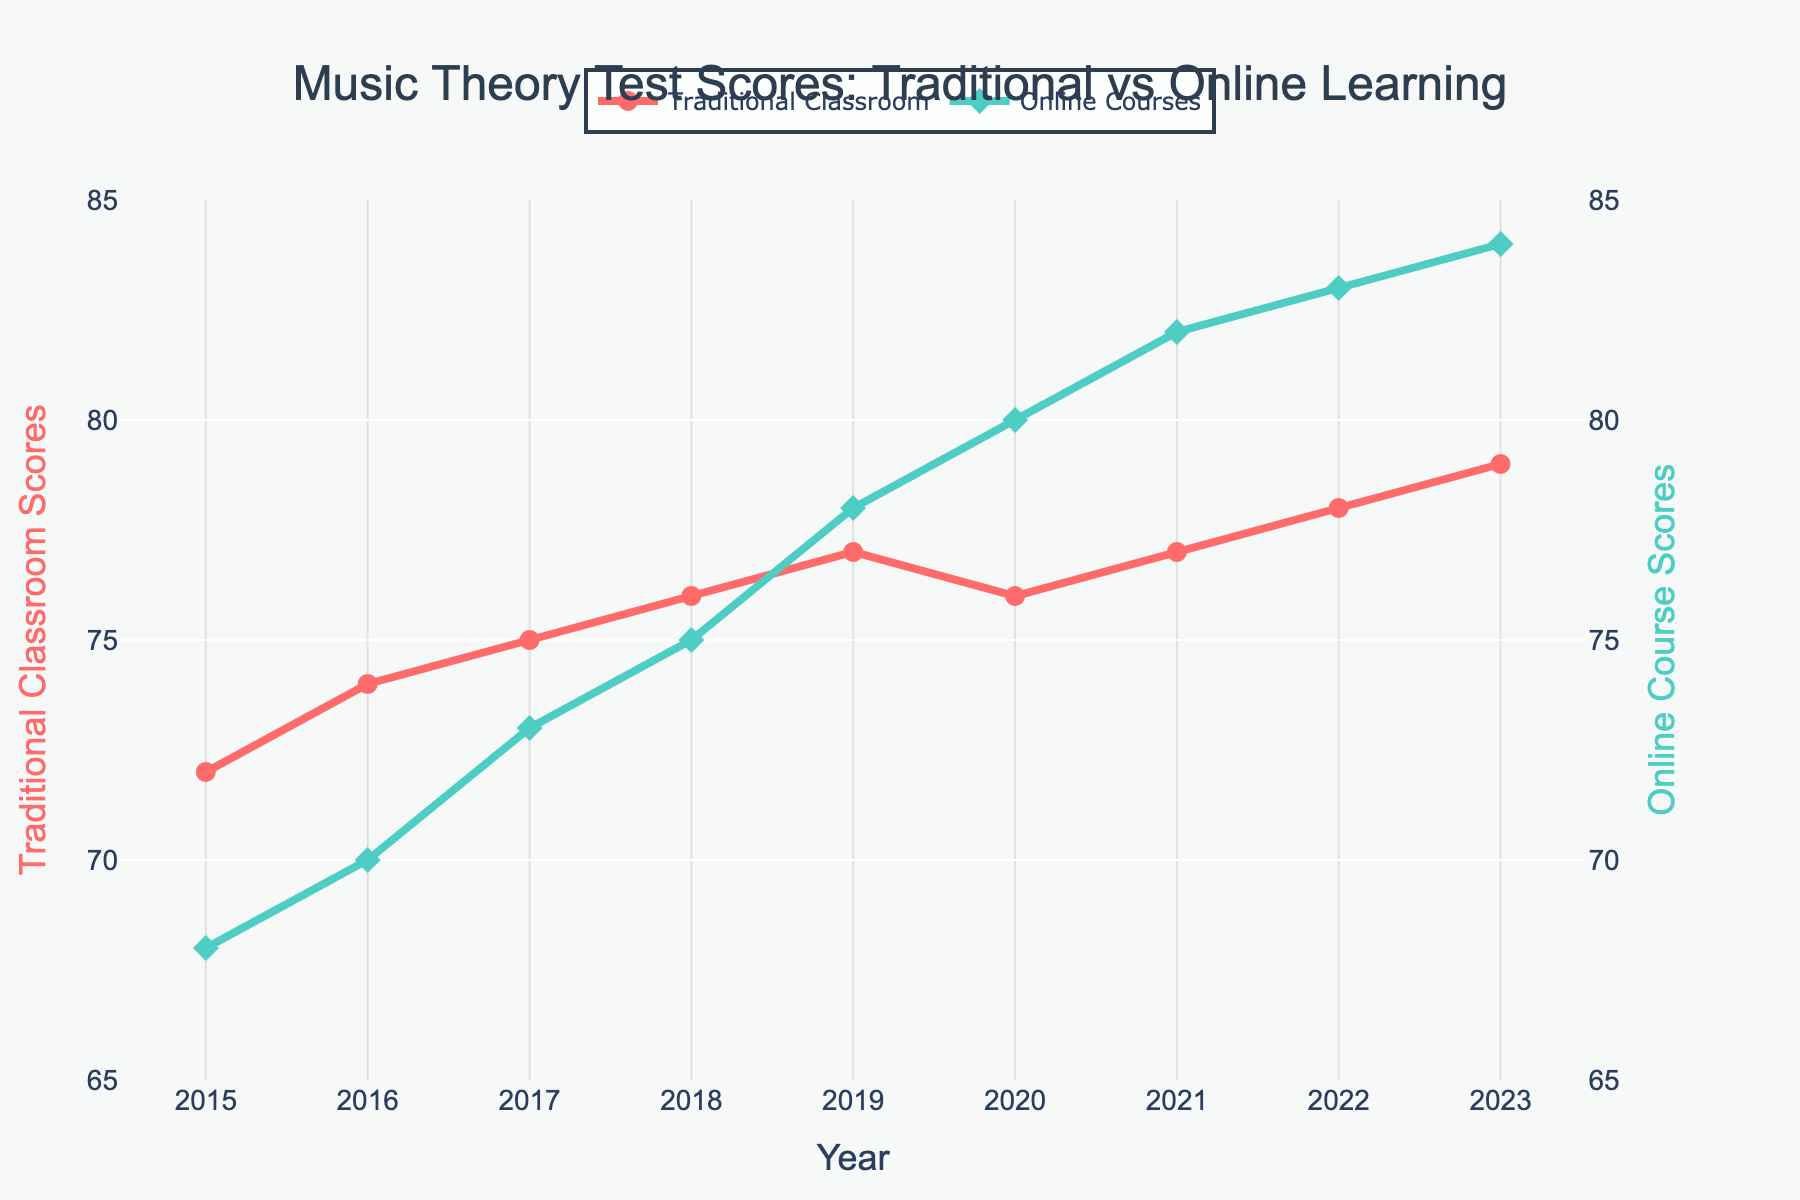What is the initial difference in test scores between traditional classroom and online courses in 2015? To find the initial difference, subtract the score of online courses from the score of traditional classroom for 2015: 72 - 68
Answer: 4 How many years after 2015 did the online courses' test scores surpass traditional classroom scores? Identify the year when online courses' test scores first exceed traditional classroom scores: Online scores first surpass in 2019. Calculate the difference: 2019 - 2015
Answer: 4 In which year were the test scores of online courses exactly equal to traditional classroom scores? Find the year where both scores are identical: This occurs in 2018 where both scores are 75
Answer: 2018 What is the average test score for traditional classroom instructions over the years provided? Calculate the average score by summing the traditional classroom scores and dividing by the number of years: (72+74+75+76+77+76+77+78+79) / 9 ≈ 76
Answer: 76 Which mode of learning showed a more rapid improvement in test scores, traditional classroom or online courses? Compare the increase in test scores from the first year to the last year for both modes of learning: 
- Traditional: 79 - 72 = 7 
- Online: 84 - 68 = 16 
Online courses showed a more rapid improvement.
Answer: Online courses What year saw the greatest increase in test scores for online courses compared to the previous year? Review the differences year over year for online courses: 
2015->2016: 2 
2016->2017: 3 
2017->2018: 2 
2018->2019: 3 
2019->2020: 2 
2020->2021: 2 
2021->2022: 1 
2022->2023: 1 
The greatest increase occurred from 2016 to 2017 and from 2018 to 2019 with an increase of 3 points.
Answer: 2016-2017 and 2018-2019 What is the difference between the highest and lowest test scores for traditional classroom instructions over the years provided? Identify highest and lowest scores: Highest is 79 (2023) and lowest is 72 (2015). Calculate the difference: 79 - 72
Answer: 7 Are there any years where the traditional classroom scores decreased compared to the previous year? If yes, in which years? Look for declines in traditional classroom scores year over year: 
2018->2019: No decrease 
2019->2020: Yes, 77 to 76 
2020->2021: No 
2022->2023: No 
So, traditional classroom scores decreased only in the year 2020.
Answer: 2020 By how much did the test scores for online learning exceed the traditional approach in 2023? Subtract the test score of traditional classroom from the online course for 2023: 84 - 79
Answer: 5 